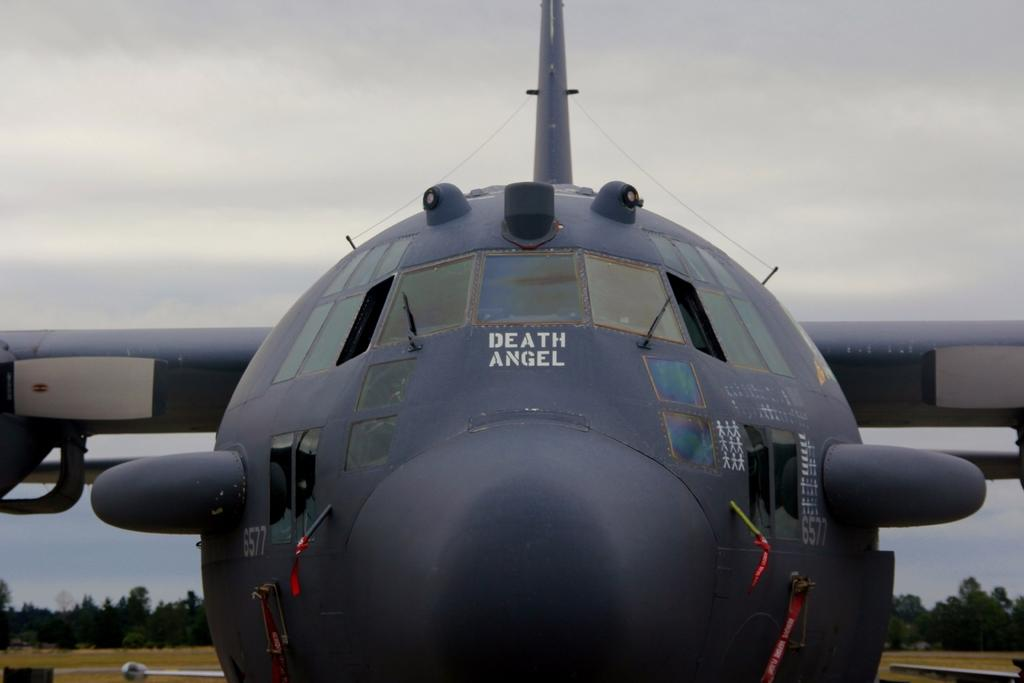<image>
Present a compact description of the photo's key features. A forward nose shot of a C-130 military aircraft with "Death Angel" painted on the front. 